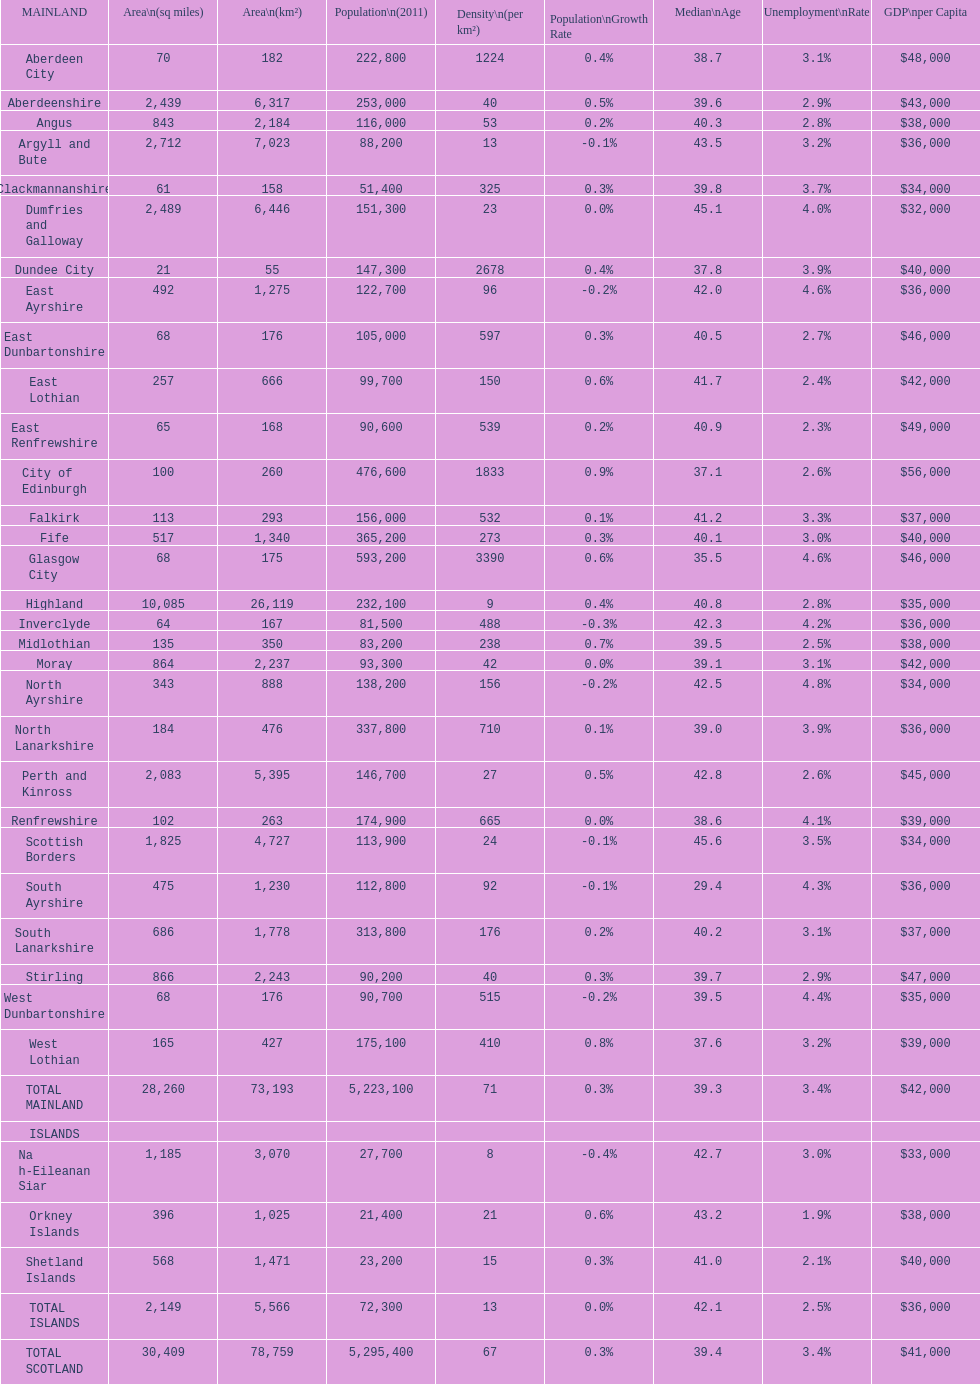What is the difference in square miles from angus and fife? 326. 